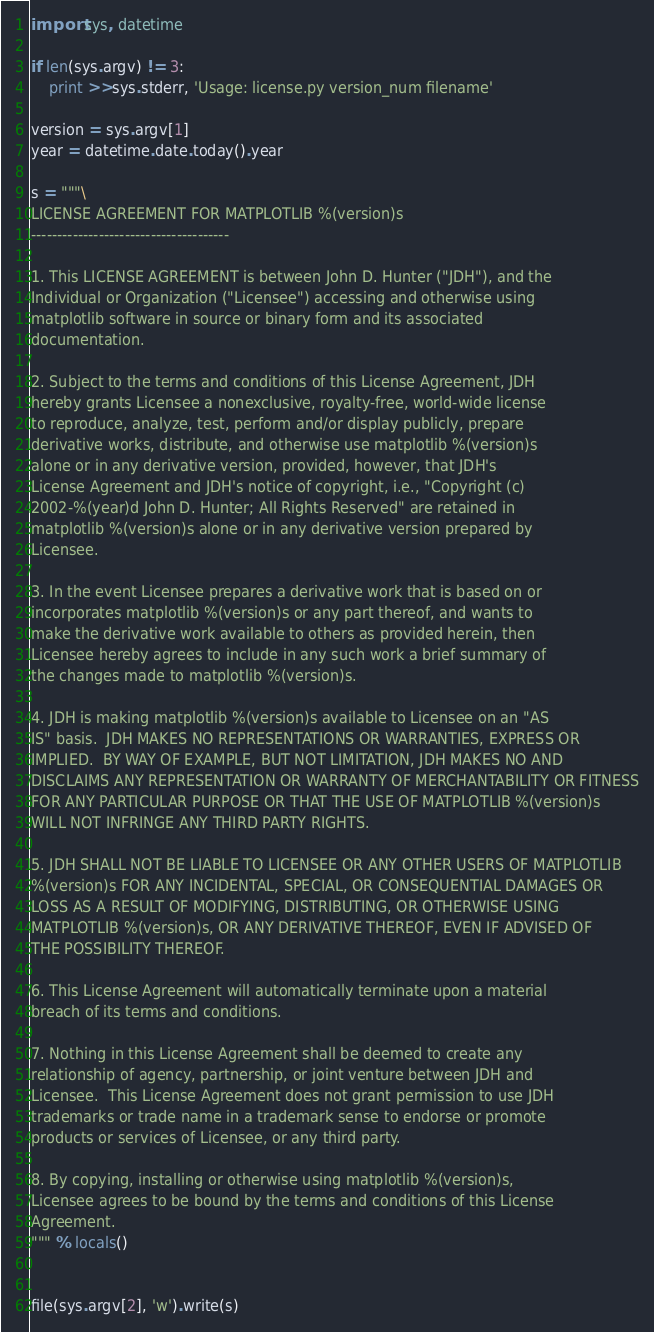Convert code to text. <code><loc_0><loc_0><loc_500><loc_500><_Python_>import sys, datetime

if len(sys.argv) != 3:
    print >>sys.stderr, 'Usage: license.py version_num filename'

version = sys.argv[1]
year = datetime.date.today().year

s = """\
LICENSE AGREEMENT FOR MATPLOTLIB %(version)s
--------------------------------------

1. This LICENSE AGREEMENT is between John D. Hunter ("JDH"), and the
Individual or Organization ("Licensee") accessing and otherwise using
matplotlib software in source or binary form and its associated
documentation.

2. Subject to the terms and conditions of this License Agreement, JDH
hereby grants Licensee a nonexclusive, royalty-free, world-wide license
to reproduce, analyze, test, perform and/or display publicly, prepare
derivative works, distribute, and otherwise use matplotlib %(version)s
alone or in any derivative version, provided, however, that JDH's
License Agreement and JDH's notice of copyright, i.e., "Copyright (c)
2002-%(year)d John D. Hunter; All Rights Reserved" are retained in
matplotlib %(version)s alone or in any derivative version prepared by
Licensee.

3. In the event Licensee prepares a derivative work that is based on or
incorporates matplotlib %(version)s or any part thereof, and wants to
make the derivative work available to others as provided herein, then
Licensee hereby agrees to include in any such work a brief summary of
the changes made to matplotlib %(version)s.

4. JDH is making matplotlib %(version)s available to Licensee on an "AS
IS" basis.  JDH MAKES NO REPRESENTATIONS OR WARRANTIES, EXPRESS OR
IMPLIED.  BY WAY OF EXAMPLE, BUT NOT LIMITATION, JDH MAKES NO AND
DISCLAIMS ANY REPRESENTATION OR WARRANTY OF MERCHANTABILITY OR FITNESS
FOR ANY PARTICULAR PURPOSE OR THAT THE USE OF MATPLOTLIB %(version)s
WILL NOT INFRINGE ANY THIRD PARTY RIGHTS.

5. JDH SHALL NOT BE LIABLE TO LICENSEE OR ANY OTHER USERS OF MATPLOTLIB
%(version)s FOR ANY INCIDENTAL, SPECIAL, OR CONSEQUENTIAL DAMAGES OR
LOSS AS A RESULT OF MODIFYING, DISTRIBUTING, OR OTHERWISE USING
MATPLOTLIB %(version)s, OR ANY DERIVATIVE THEREOF, EVEN IF ADVISED OF
THE POSSIBILITY THEREOF.

6. This License Agreement will automatically terminate upon a material
breach of its terms and conditions.

7. Nothing in this License Agreement shall be deemed to create any
relationship of agency, partnership, or joint venture between JDH and
Licensee.  This License Agreement does not grant permission to use JDH
trademarks or trade name in a trademark sense to endorse or promote
products or services of Licensee, or any third party.

8. By copying, installing or otherwise using matplotlib %(version)s,
Licensee agrees to be bound by the terms and conditions of this License
Agreement.
""" % locals()


file(sys.argv[2], 'w').write(s)

</code> 